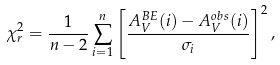Convert formula to latex. <formula><loc_0><loc_0><loc_500><loc_500>\chi ^ { 2 } _ { r } = \frac { 1 } { n - 2 } \sum _ { i = 1 } ^ { n } \left [ \frac { A _ { V } ^ { B E } ( i ) - A _ { V } ^ { o b s } ( i ) } { \sigma _ { i } } \right ] ^ { 2 } ,</formula> 